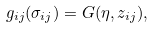Convert formula to latex. <formula><loc_0><loc_0><loc_500><loc_500>g _ { i j } ( \sigma _ { i j } ) = G ( \eta , z _ { i j } ) ,</formula> 